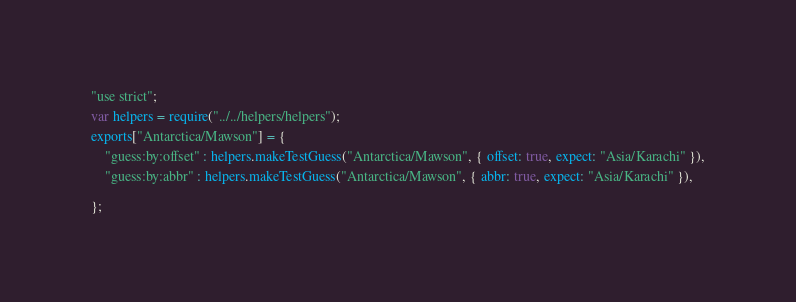Convert code to text. <code><loc_0><loc_0><loc_500><loc_500><_JavaScript_>"use strict";

var helpers = require("../../helpers/helpers");

exports["Antarctica/Mawson"] = {

	"guess:by:offset" : helpers.makeTestGuess("Antarctica/Mawson", { offset: true, expect: "Asia/Karachi" }),

	"guess:by:abbr" : helpers.makeTestGuess("Antarctica/Mawson", { abbr: true, expect: "Asia/Karachi" }),


};</code> 